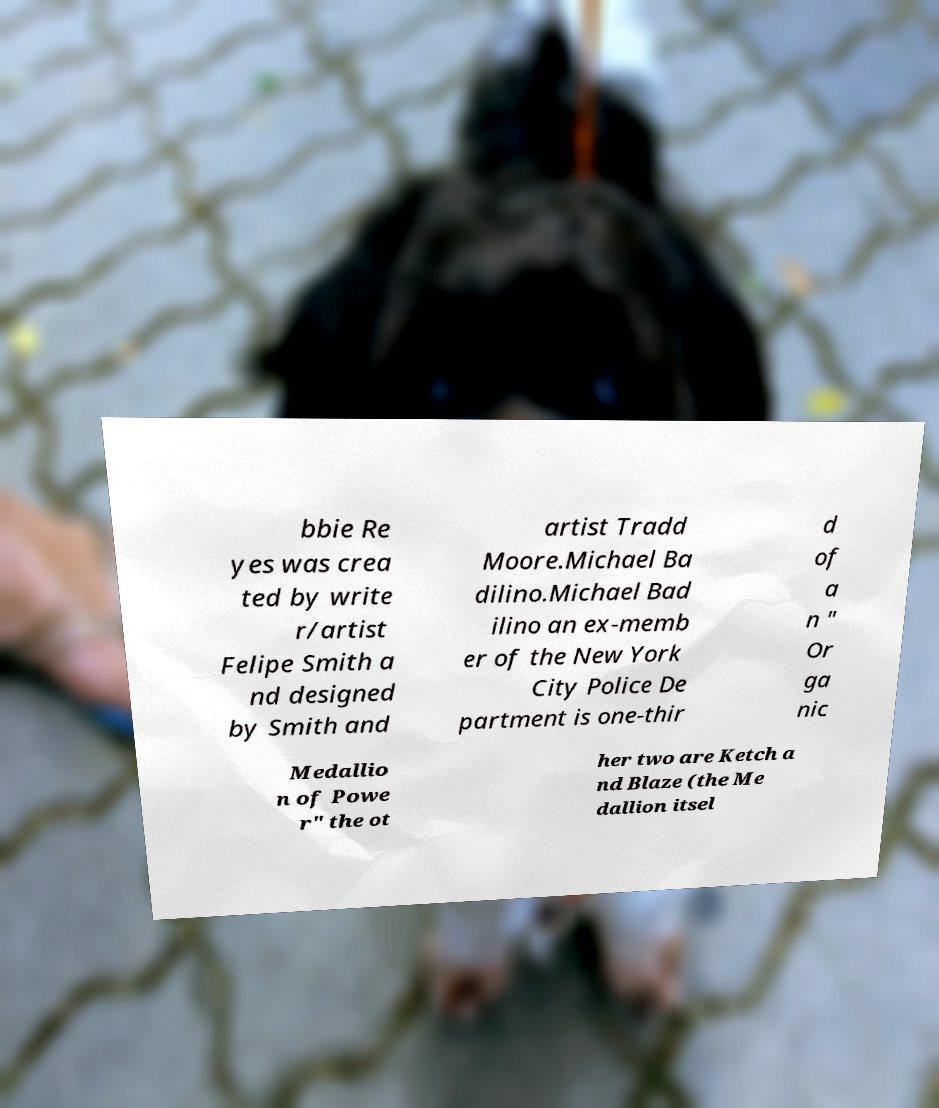What messages or text are displayed in this image? I need them in a readable, typed format. bbie Re yes was crea ted by write r/artist Felipe Smith a nd designed by Smith and artist Tradd Moore.Michael Ba dilino.Michael Bad ilino an ex-memb er of the New York City Police De partment is one-thir d of a n " Or ga nic Medallio n of Powe r" the ot her two are Ketch a nd Blaze (the Me dallion itsel 